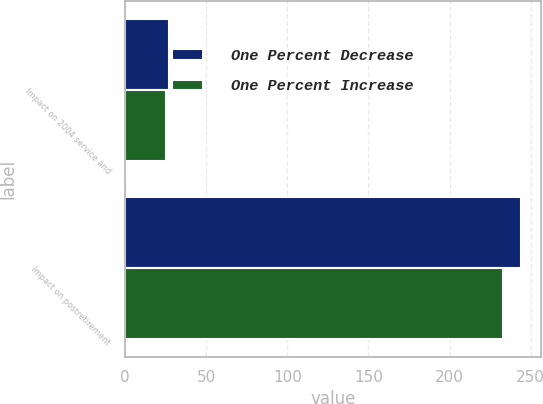<chart> <loc_0><loc_0><loc_500><loc_500><stacked_bar_chart><ecel><fcel>Impact on 2004 service and<fcel>Impact on postretirement<nl><fcel>One Percent Decrease<fcel>27<fcel>244<nl><fcel>One Percent Increase<fcel>25<fcel>233<nl></chart> 